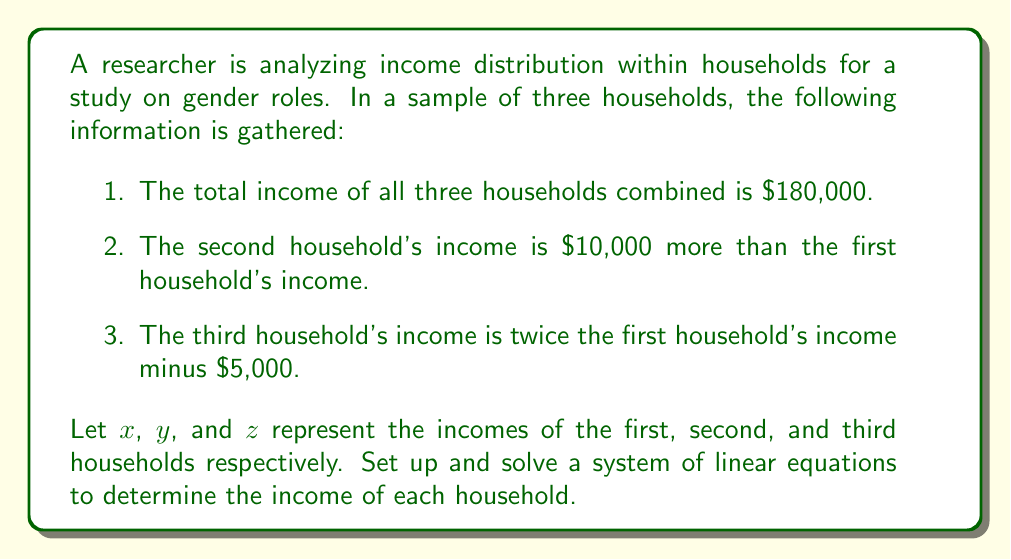Provide a solution to this math problem. Let's approach this step-by-step:

1) First, we'll set up our system of linear equations based on the given information:

   $$\begin{cases}
   x + y + z = 180000 & \text{(total income)}\\
   y = x + 10000 & \text{(second household)}\\
   z = 2x - 5000 & \text{(third household)}
   \end{cases}$$

2) We can substitute the expressions for $y$ and $z$ into the first equation:

   $x + (x + 10000) + (2x - 5000) = 180000$

3) Simplify:

   $x + x + 10000 + 2x - 5000 = 180000$
   $4x + 5000 = 180000$

4) Solve for $x$:

   $4x = 175000$
   $x = 43750$

5) Now that we know $x$, we can find $y$ and $z$:

   $y = x + 10000 = 43750 + 10000 = 53750$

   $z = 2x - 5000 = 2(43750) - 5000 = 82500$

6) Let's verify our solution:

   $x + y + z = 43750 + 53750 + 82500 = 180000$

   This checks out with our original total income.
Answer: The incomes of the three households are:
First household (x): $43,750
Second household (y): $53,750
Third household (z): $82,500 